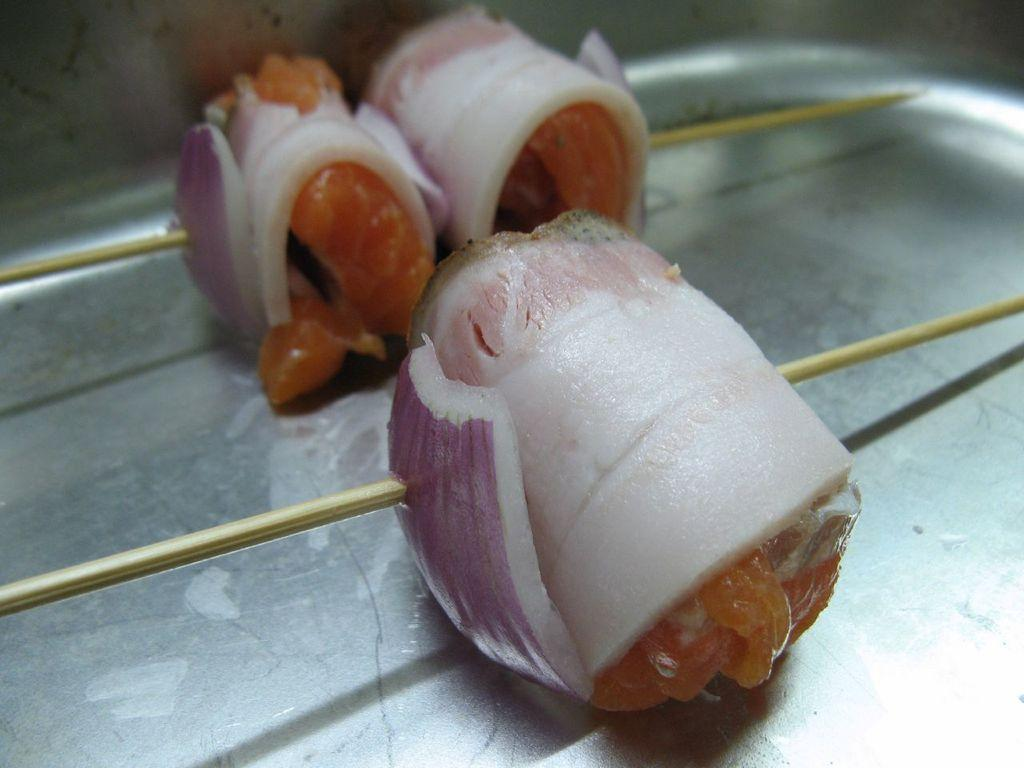What type of food is present on sticks in the image? The facts provided do not specify the type of food on sticks. However, we can confirm that there are food items present on sticks in the image. How are the food items arranged on the sticks? The facts provided do not specify the arrangement of the food items on the sticks. Are there any additional items or decorations present with the food items on sticks? The facts provided do not specify any additional items or decorations. What is the distance between the gold and the food items on sticks in the image? There is no gold present in the image, so it is not possible to determine the distance between gold and the food items on sticks. 